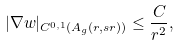<formula> <loc_0><loc_0><loc_500><loc_500>| \nabla w | _ { C ^ { 0 , 1 } ( A _ { g } ( r , s r ) ) } \leq \frac { C } { r ^ { 2 } } ,</formula> 